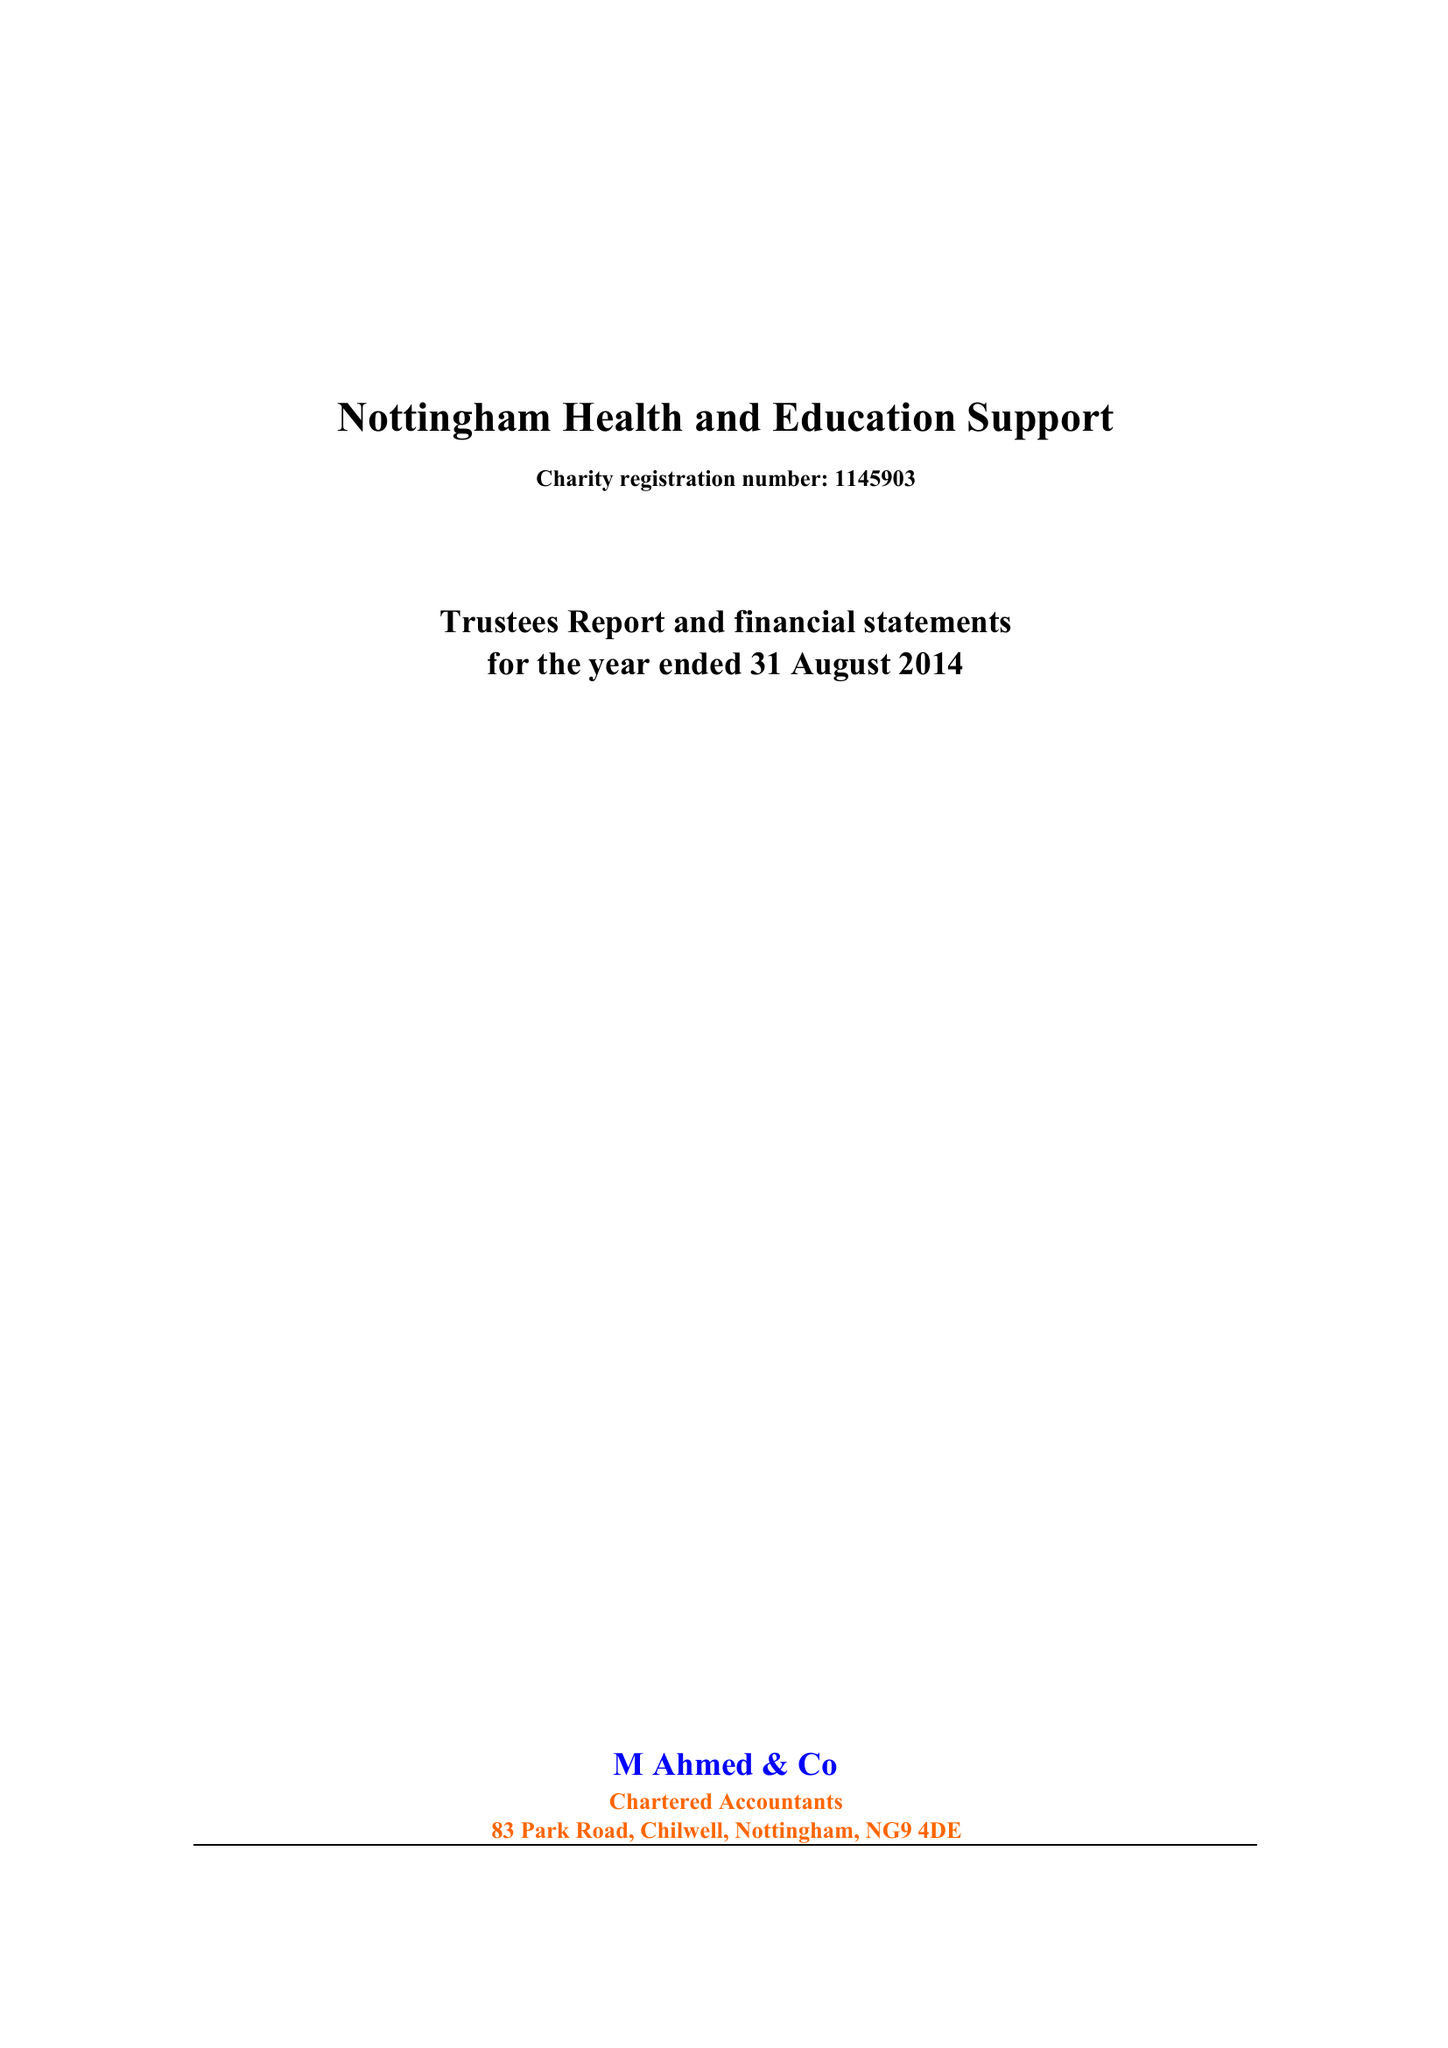What is the value for the address__street_line?
Answer the question using a single word or phrase. 9 CLAYGATE 